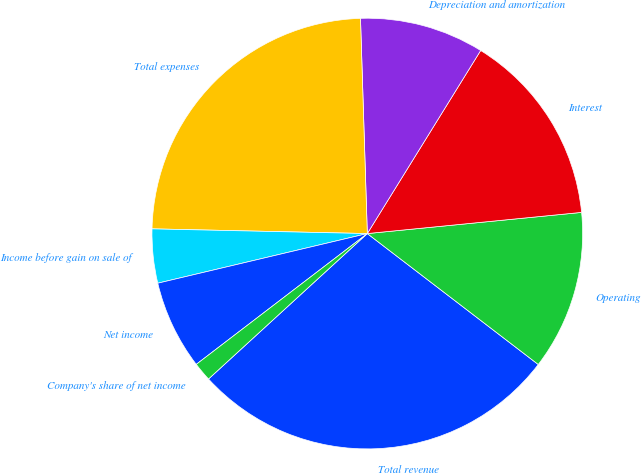Convert chart. <chart><loc_0><loc_0><loc_500><loc_500><pie_chart><fcel>Total revenue<fcel>Operating<fcel>Interest<fcel>Depreciation and amortization<fcel>Total expenses<fcel>Income before gain on sale of<fcel>Net income<fcel>Company's share of net income<nl><fcel>27.8%<fcel>11.97%<fcel>14.61%<fcel>9.33%<fcel>24.15%<fcel>4.05%<fcel>6.69%<fcel>1.41%<nl></chart> 